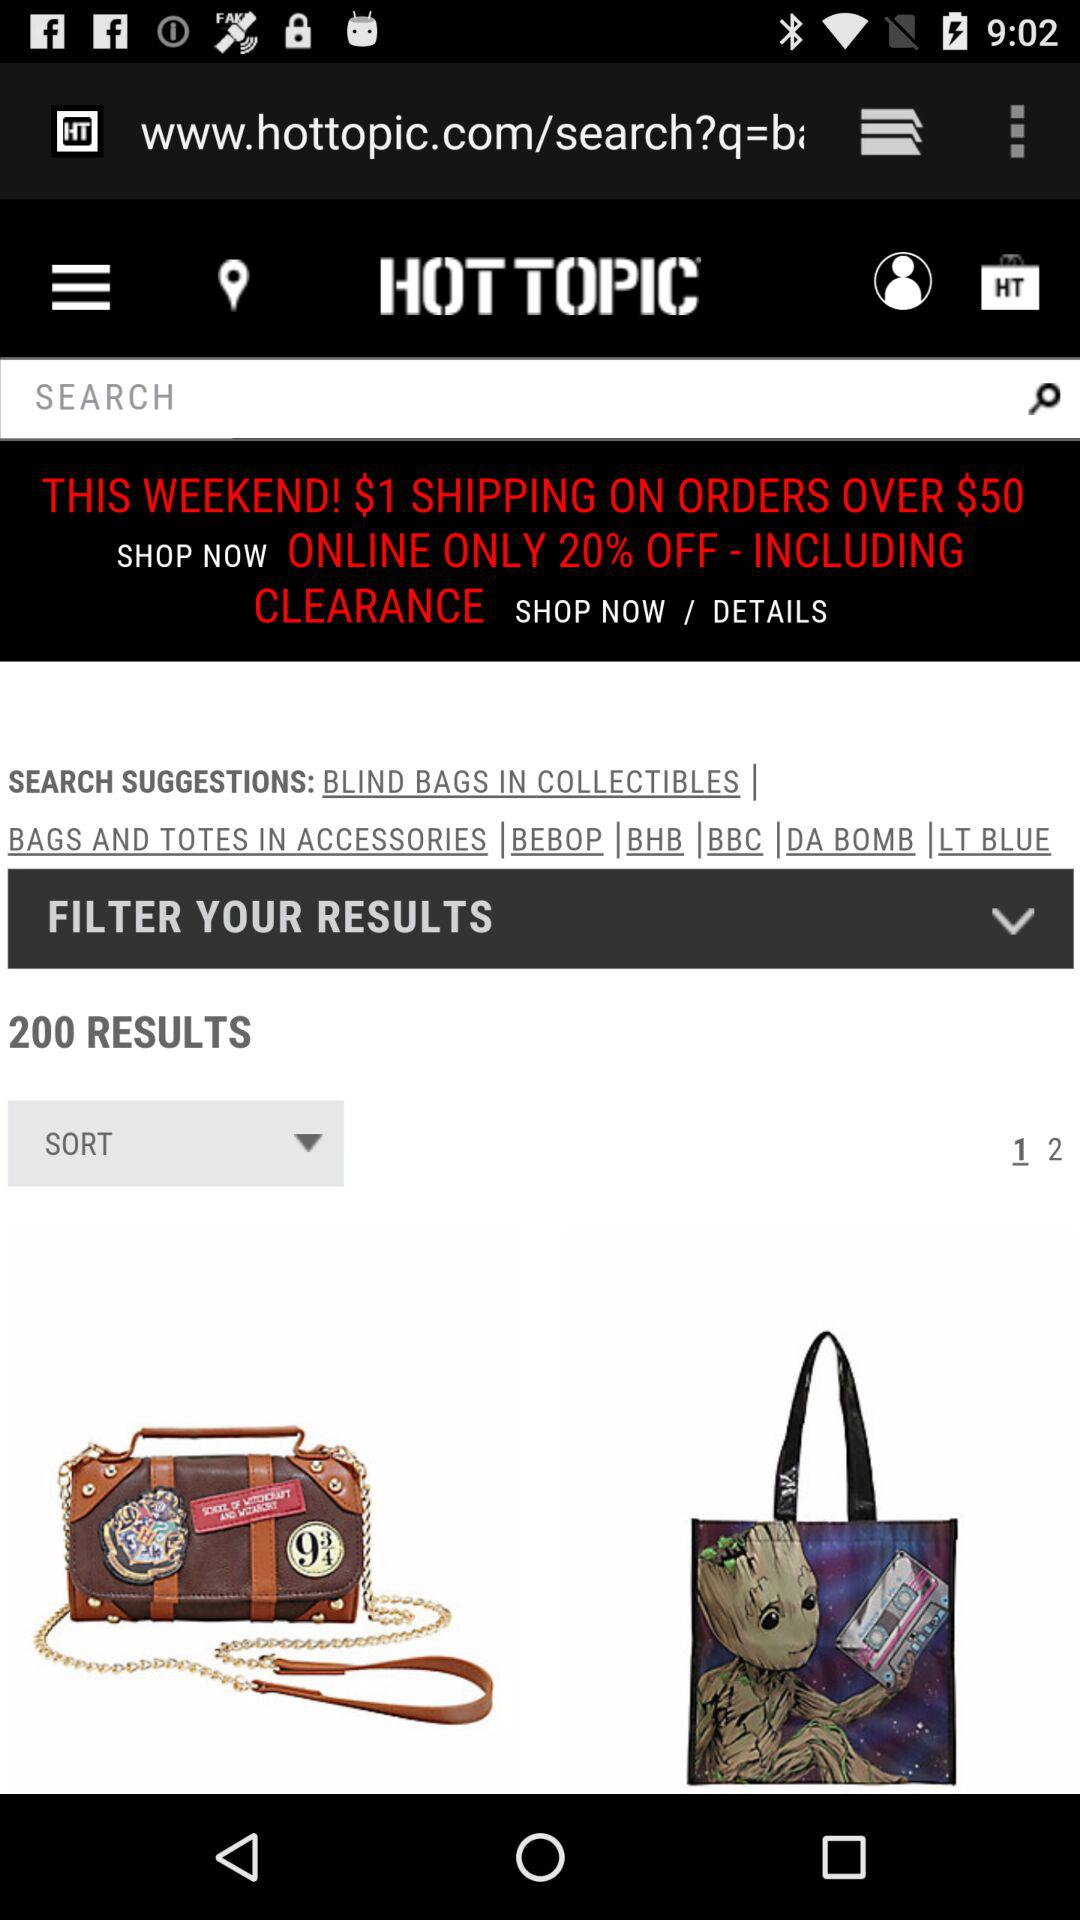How many results are there? There are 200 results. 